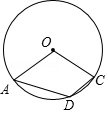Assuming the measure of angle AOC is 120°, could you calculate the measure of angle ADC? If the measure of angle AOC, which is the central angle, is 120°, then the measure of the inscribed angle ADC would be half of 120°, which is 60°. This is due to the inscribed angle theorem that states the inscribed angle is half the central angle that subtends the same arc. 